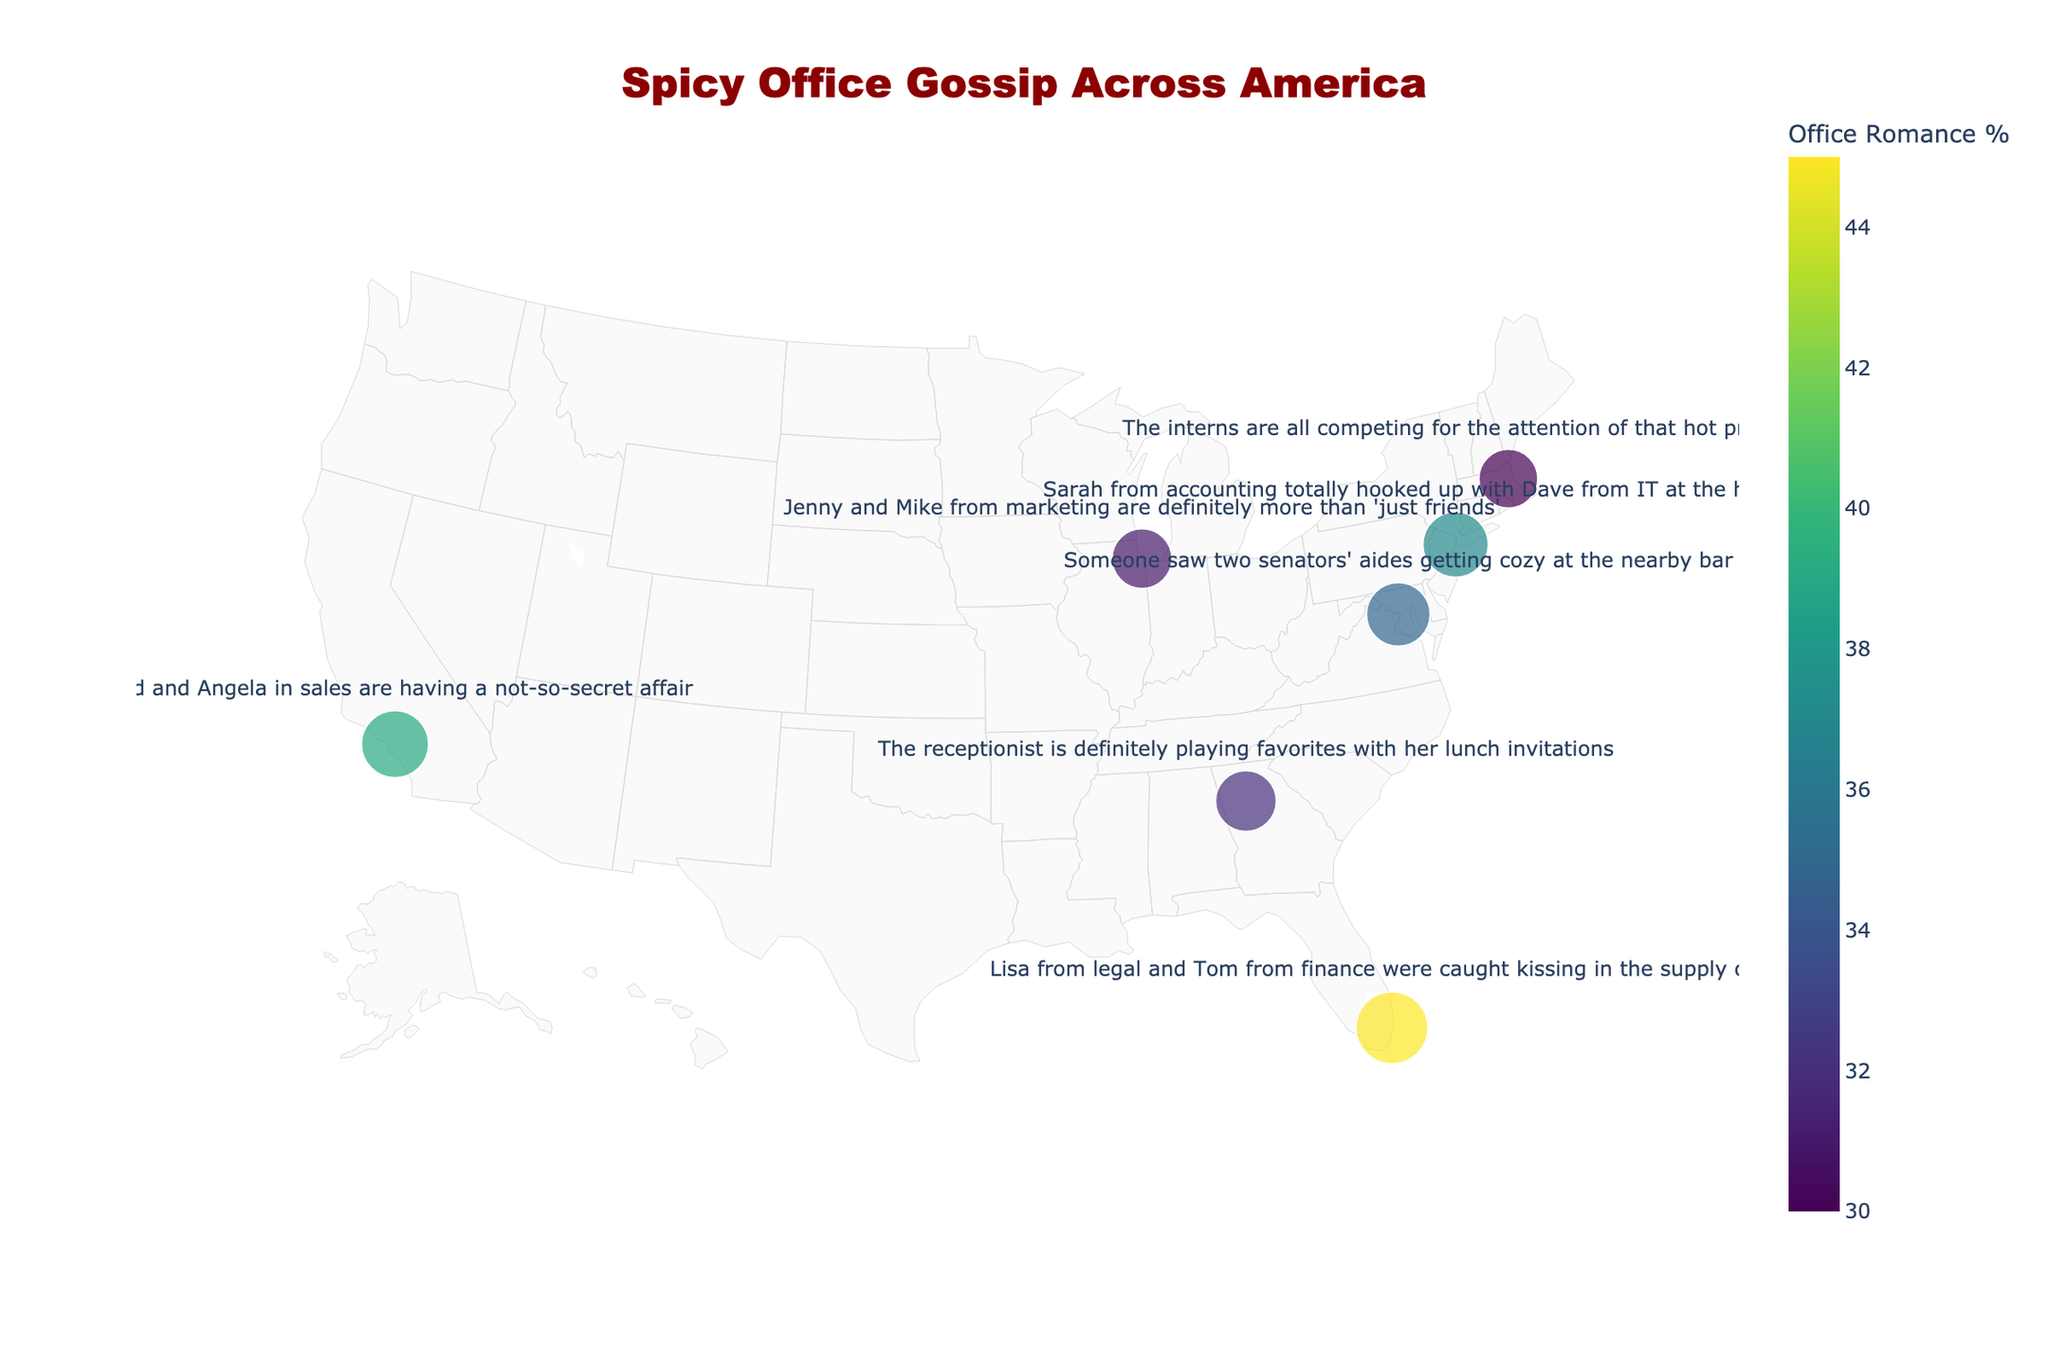How many cities are mapped in this figure? Identify the number of distinct data points representing cities on the map.
Answer: 7 Which city has the highest percentage of office romance? Locate the city with the largest size marker on the map, which represents the highest percentage.
Answer: Miami What is the title of the figure? Read the text positioned at the top center of the figure.
Answer: Spicy Office Gossip Across America Which city has the lowest percentage of office romance? Locate the city with the smallest size marker on the map, indicating the lowest percentage.
Answer: Boston What percentage of office romances is associated with Washington D.C.? Hover over Washington D.C. on the map to find the romance percentage in the hover text.
Answer: 35% How do the office romance percentages of New York City and Boston compare? Compare New York City's 37% with Boston's 30%. New York City has a higher percentage than Boston.
Answer: New York City has a higher percentage What's the average percentage of office romance across all the cities? Sum all percentages: (37 + 31 + 39 + 45 + 30 + 35 + 32) = 249, then divide by the number of cities, which is 7. The average is 249/7 ≈ 35.6
Answer: 35.6% Which city’s gossip mentions a project manager and what is the office romance percentage there? Identify the city with gossip mentioning a project manager (Boston) and note its romance percentage (30%).
Answer: Boston, 30% What does the hover text reveal when pointing at Los Angeles? Hover over Los Angeles on the map, the hover text will show the gossip and romance percentage associated with it.
Answer: Brad and Angela in sales are having a not-so-secret affair, Romance %: 39% Compare the office romance percentages between cities on the East Coast (New York City, Miami) and the West Coast (Los Angeles). Which coast has the higher average percentage? Calculate the average for the East Coast: (37 + 45)/2 = 41%, and for the West Coast: 39%. The East Coast has a higher average percentage.
Answer: East Coast 